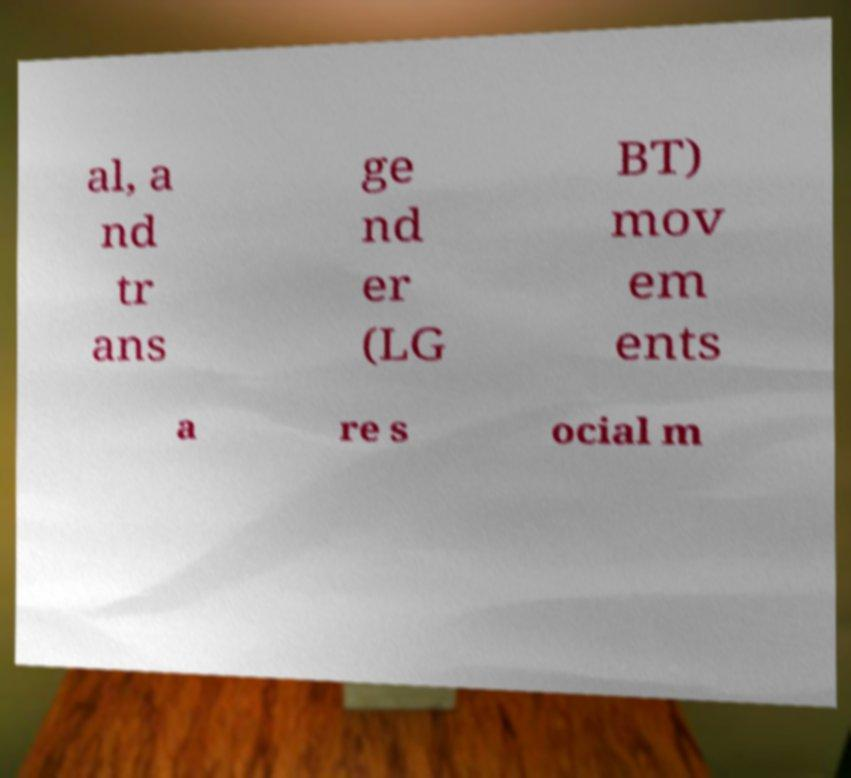Please read and relay the text visible in this image. What does it say? al, a nd tr ans ge nd er (LG BT) mov em ents a re s ocial m 